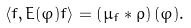Convert formula to latex. <formula><loc_0><loc_0><loc_500><loc_500>\left \langle f , E ( \varphi ) f \right \rangle = \left ( \mu _ { f } \ast \rho \right ) ( \varphi ) .</formula> 